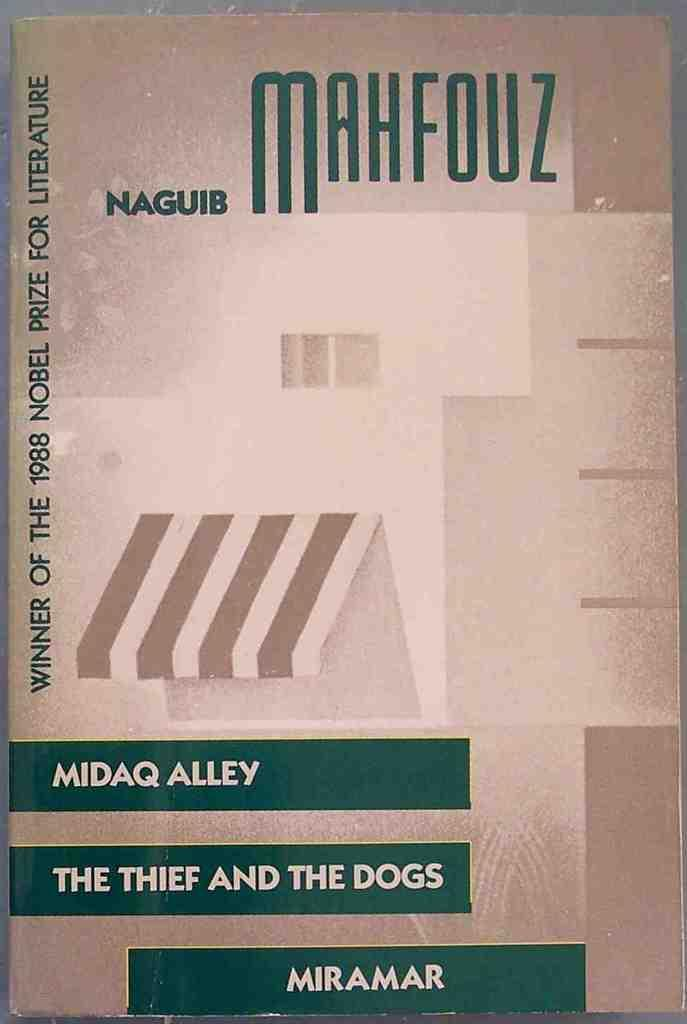<image>
Write a terse but informative summary of the picture. A collection of works by Naguib Mahfouz won the 1998 Nobel Prize for Literature. 